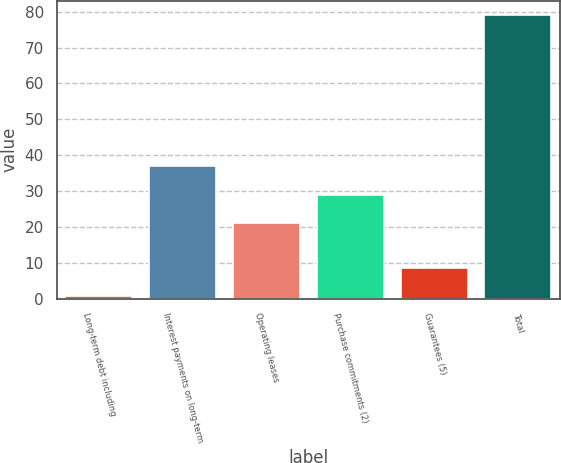<chart> <loc_0><loc_0><loc_500><loc_500><bar_chart><fcel>Long-term debt including<fcel>Interest payments on long-term<fcel>Operating leases<fcel>Purchase commitments (2)<fcel>Guarantees (5)<fcel>Total<nl><fcel>0.8<fcel>36.86<fcel>21.2<fcel>29.03<fcel>8.63<fcel>79.1<nl></chart> 